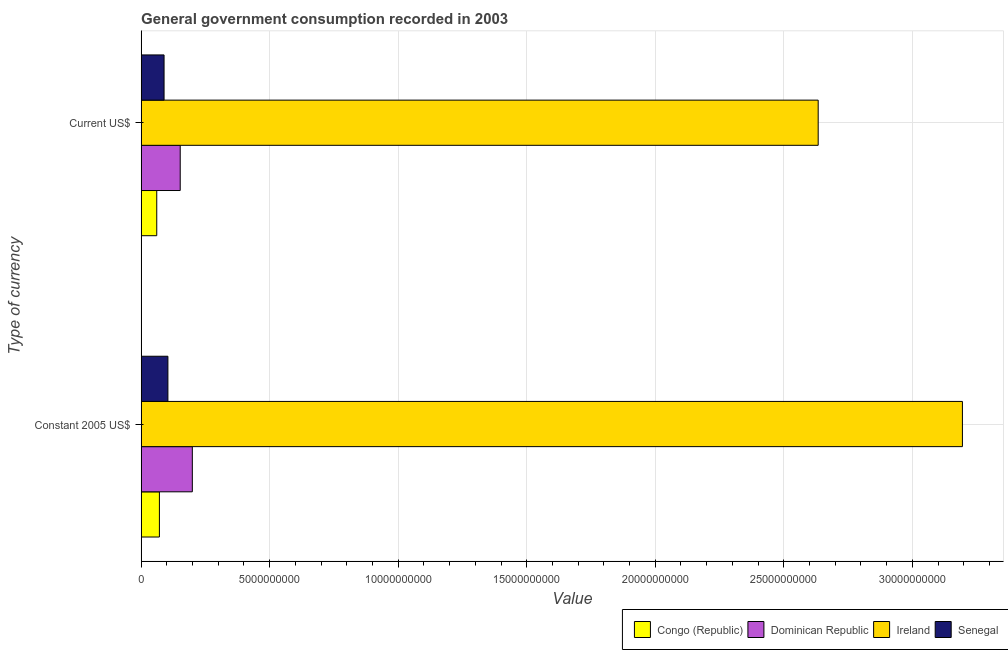How many groups of bars are there?
Give a very brief answer. 2. Are the number of bars per tick equal to the number of legend labels?
Your response must be concise. Yes. How many bars are there on the 2nd tick from the top?
Give a very brief answer. 4. How many bars are there on the 1st tick from the bottom?
Keep it short and to the point. 4. What is the label of the 2nd group of bars from the top?
Your response must be concise. Constant 2005 US$. What is the value consumed in constant 2005 us$ in Senegal?
Keep it short and to the point. 1.04e+09. Across all countries, what is the maximum value consumed in current us$?
Provide a succinct answer. 2.63e+1. Across all countries, what is the minimum value consumed in current us$?
Offer a terse response. 6.07e+08. In which country was the value consumed in constant 2005 us$ maximum?
Keep it short and to the point. Ireland. In which country was the value consumed in constant 2005 us$ minimum?
Your answer should be very brief. Congo (Republic). What is the total value consumed in current us$ in the graph?
Ensure brevity in your answer.  2.94e+1. What is the difference between the value consumed in current us$ in Senegal and that in Dominican Republic?
Offer a terse response. -6.28e+08. What is the difference between the value consumed in current us$ in Senegal and the value consumed in constant 2005 us$ in Ireland?
Give a very brief answer. -3.11e+1. What is the average value consumed in constant 2005 us$ per country?
Give a very brief answer. 8.92e+09. What is the difference between the value consumed in constant 2005 us$ and value consumed in current us$ in Congo (Republic)?
Offer a terse response. 1.03e+08. What is the ratio of the value consumed in constant 2005 us$ in Senegal to that in Dominican Republic?
Offer a very short reply. 0.52. What does the 2nd bar from the top in Constant 2005 US$ represents?
Ensure brevity in your answer.  Ireland. What does the 1st bar from the bottom in Current US$ represents?
Provide a short and direct response. Congo (Republic). What is the difference between two consecutive major ticks on the X-axis?
Keep it short and to the point. 5.00e+09. Are the values on the major ticks of X-axis written in scientific E-notation?
Offer a very short reply. No. Does the graph contain any zero values?
Your response must be concise. No. Where does the legend appear in the graph?
Offer a very short reply. Bottom right. How many legend labels are there?
Keep it short and to the point. 4. How are the legend labels stacked?
Provide a short and direct response. Horizontal. What is the title of the graph?
Ensure brevity in your answer.  General government consumption recorded in 2003. What is the label or title of the X-axis?
Your response must be concise. Value. What is the label or title of the Y-axis?
Provide a short and direct response. Type of currency. What is the Value in Congo (Republic) in Constant 2005 US$?
Make the answer very short. 7.10e+08. What is the Value of Dominican Republic in Constant 2005 US$?
Your answer should be very brief. 1.99e+09. What is the Value of Ireland in Constant 2005 US$?
Give a very brief answer. 3.19e+1. What is the Value in Senegal in Constant 2005 US$?
Provide a short and direct response. 1.04e+09. What is the Value of Congo (Republic) in Current US$?
Your answer should be compact. 6.07e+08. What is the Value of Dominican Republic in Current US$?
Make the answer very short. 1.52e+09. What is the Value of Ireland in Current US$?
Make the answer very short. 2.63e+1. What is the Value of Senegal in Current US$?
Offer a very short reply. 8.92e+08. Across all Type of currency, what is the maximum Value of Congo (Republic)?
Make the answer very short. 7.10e+08. Across all Type of currency, what is the maximum Value of Dominican Republic?
Provide a succinct answer. 1.99e+09. Across all Type of currency, what is the maximum Value of Ireland?
Offer a terse response. 3.19e+1. Across all Type of currency, what is the maximum Value of Senegal?
Keep it short and to the point. 1.04e+09. Across all Type of currency, what is the minimum Value of Congo (Republic)?
Provide a short and direct response. 6.07e+08. Across all Type of currency, what is the minimum Value of Dominican Republic?
Give a very brief answer. 1.52e+09. Across all Type of currency, what is the minimum Value of Ireland?
Provide a succinct answer. 2.63e+1. Across all Type of currency, what is the minimum Value of Senegal?
Make the answer very short. 8.92e+08. What is the total Value in Congo (Republic) in the graph?
Offer a very short reply. 1.32e+09. What is the total Value in Dominican Republic in the graph?
Your response must be concise. 3.51e+09. What is the total Value in Ireland in the graph?
Your answer should be compact. 5.83e+1. What is the total Value of Senegal in the graph?
Your response must be concise. 1.93e+09. What is the difference between the Value in Congo (Republic) in Constant 2005 US$ and that in Current US$?
Make the answer very short. 1.03e+08. What is the difference between the Value of Dominican Republic in Constant 2005 US$ and that in Current US$?
Your answer should be compact. 4.71e+08. What is the difference between the Value in Ireland in Constant 2005 US$ and that in Current US$?
Give a very brief answer. 5.61e+09. What is the difference between the Value in Senegal in Constant 2005 US$ and that in Current US$?
Your answer should be very brief. 1.49e+08. What is the difference between the Value in Congo (Republic) in Constant 2005 US$ and the Value in Dominican Republic in Current US$?
Give a very brief answer. -8.10e+08. What is the difference between the Value of Congo (Republic) in Constant 2005 US$ and the Value of Ireland in Current US$?
Your response must be concise. -2.56e+1. What is the difference between the Value in Congo (Republic) in Constant 2005 US$ and the Value in Senegal in Current US$?
Your answer should be very brief. -1.81e+08. What is the difference between the Value of Dominican Republic in Constant 2005 US$ and the Value of Ireland in Current US$?
Your answer should be compact. -2.43e+1. What is the difference between the Value of Dominican Republic in Constant 2005 US$ and the Value of Senegal in Current US$?
Your answer should be very brief. 1.10e+09. What is the difference between the Value of Ireland in Constant 2005 US$ and the Value of Senegal in Current US$?
Make the answer very short. 3.11e+1. What is the average Value in Congo (Republic) per Type of currency?
Give a very brief answer. 6.59e+08. What is the average Value of Dominican Republic per Type of currency?
Provide a succinct answer. 1.76e+09. What is the average Value in Ireland per Type of currency?
Give a very brief answer. 2.91e+1. What is the average Value in Senegal per Type of currency?
Your response must be concise. 9.66e+08. What is the difference between the Value in Congo (Republic) and Value in Dominican Republic in Constant 2005 US$?
Keep it short and to the point. -1.28e+09. What is the difference between the Value in Congo (Republic) and Value in Ireland in Constant 2005 US$?
Keep it short and to the point. -3.12e+1. What is the difference between the Value in Congo (Republic) and Value in Senegal in Constant 2005 US$?
Your response must be concise. -3.30e+08. What is the difference between the Value in Dominican Republic and Value in Ireland in Constant 2005 US$?
Offer a very short reply. -3.00e+1. What is the difference between the Value in Dominican Republic and Value in Senegal in Constant 2005 US$?
Offer a very short reply. 9.50e+08. What is the difference between the Value in Ireland and Value in Senegal in Constant 2005 US$?
Your response must be concise. 3.09e+1. What is the difference between the Value in Congo (Republic) and Value in Dominican Republic in Current US$?
Your answer should be very brief. -9.13e+08. What is the difference between the Value in Congo (Republic) and Value in Ireland in Current US$?
Offer a terse response. -2.57e+1. What is the difference between the Value of Congo (Republic) and Value of Senegal in Current US$?
Your answer should be compact. -2.85e+08. What is the difference between the Value of Dominican Republic and Value of Ireland in Current US$?
Provide a short and direct response. -2.48e+1. What is the difference between the Value in Dominican Republic and Value in Senegal in Current US$?
Ensure brevity in your answer.  6.28e+08. What is the difference between the Value in Ireland and Value in Senegal in Current US$?
Your answer should be compact. 2.54e+1. What is the ratio of the Value of Congo (Republic) in Constant 2005 US$ to that in Current US$?
Your response must be concise. 1.17. What is the ratio of the Value of Dominican Republic in Constant 2005 US$ to that in Current US$?
Your answer should be very brief. 1.31. What is the ratio of the Value in Ireland in Constant 2005 US$ to that in Current US$?
Provide a succinct answer. 1.21. What is the ratio of the Value of Senegal in Constant 2005 US$ to that in Current US$?
Offer a very short reply. 1.17. What is the difference between the highest and the second highest Value of Congo (Republic)?
Ensure brevity in your answer.  1.03e+08. What is the difference between the highest and the second highest Value of Dominican Republic?
Your answer should be compact. 4.71e+08. What is the difference between the highest and the second highest Value in Ireland?
Keep it short and to the point. 5.61e+09. What is the difference between the highest and the second highest Value of Senegal?
Offer a very short reply. 1.49e+08. What is the difference between the highest and the lowest Value of Congo (Republic)?
Give a very brief answer. 1.03e+08. What is the difference between the highest and the lowest Value in Dominican Republic?
Provide a short and direct response. 4.71e+08. What is the difference between the highest and the lowest Value of Ireland?
Provide a short and direct response. 5.61e+09. What is the difference between the highest and the lowest Value of Senegal?
Your answer should be very brief. 1.49e+08. 